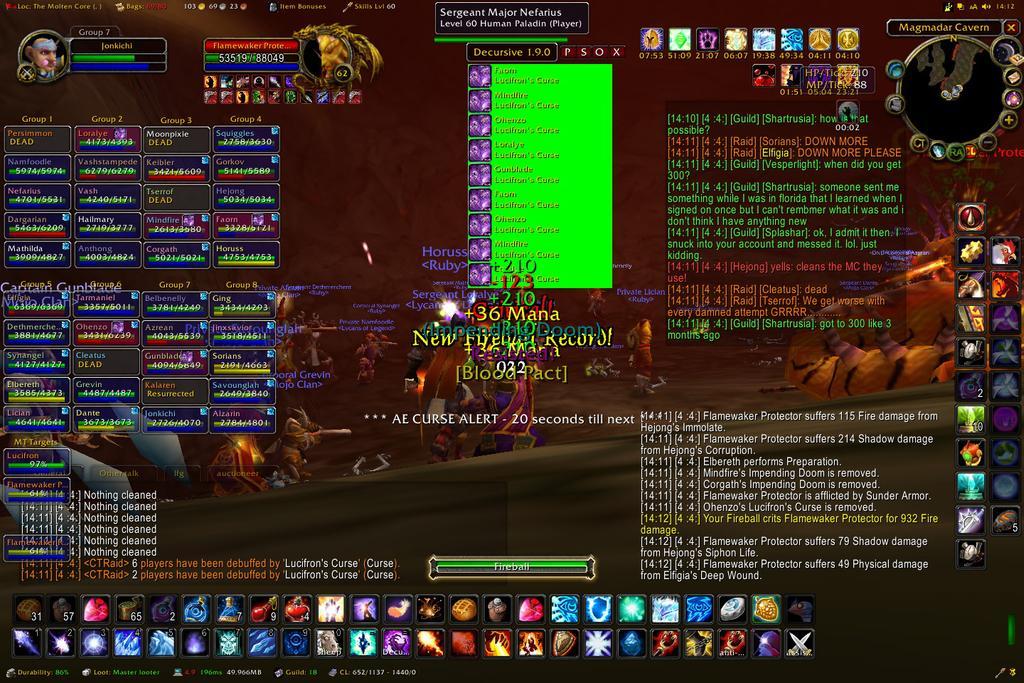Could you give a brief overview of what you see in this image? This is an animated image. In the center we can see the pictures of some creatures seems to be the persons and we can see the pictures of many number of objects and we can see the text on the image and we can also see the numbers on the image. 